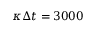Convert formula to latex. <formula><loc_0><loc_0><loc_500><loc_500>\kappa \Delta t = 3 0 0 0</formula> 